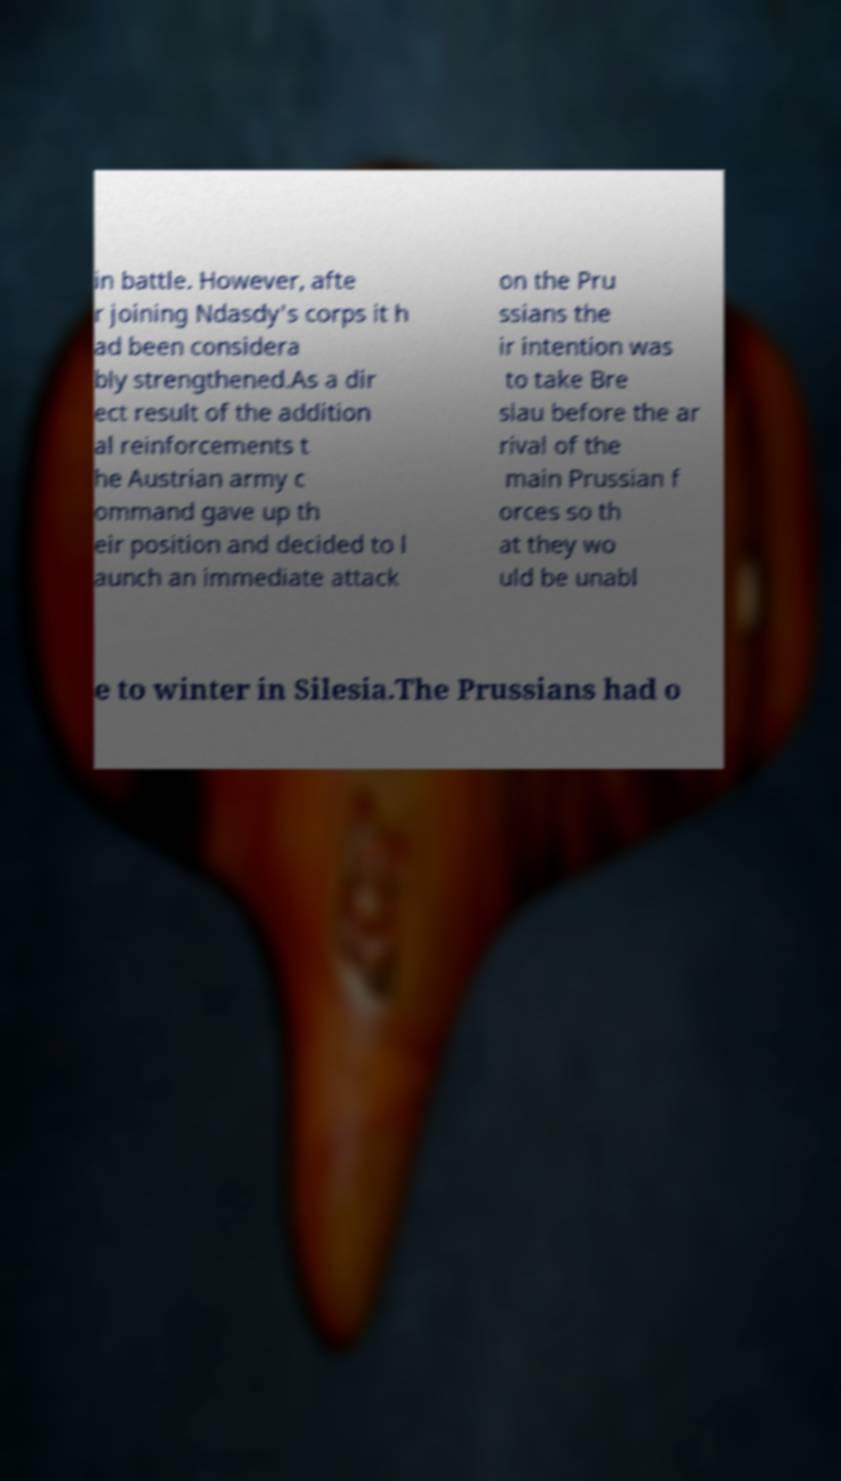Can you accurately transcribe the text from the provided image for me? in battle. However, afte r joining Ndasdy's corps it h ad been considera bly strengthened.As a dir ect result of the addition al reinforcements t he Austrian army c ommand gave up th eir position and decided to l aunch an immediate attack on the Pru ssians the ir intention was to take Bre slau before the ar rival of the main Prussian f orces so th at they wo uld be unabl e to winter in Silesia.The Prussians had o 